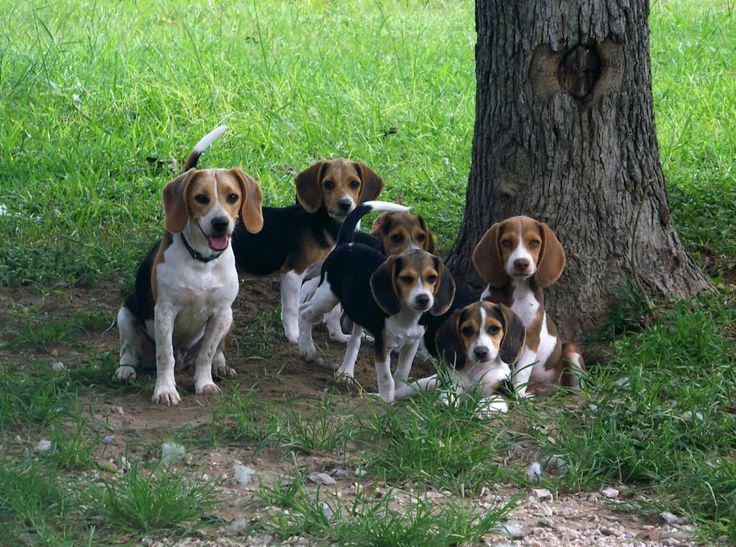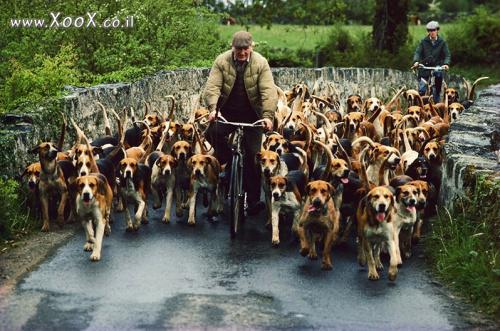The first image is the image on the left, the second image is the image on the right. Given the left and right images, does the statement "One image shows a man in a hat leading a pack of dogs down a paved country lane." hold true? Answer yes or no. Yes. 